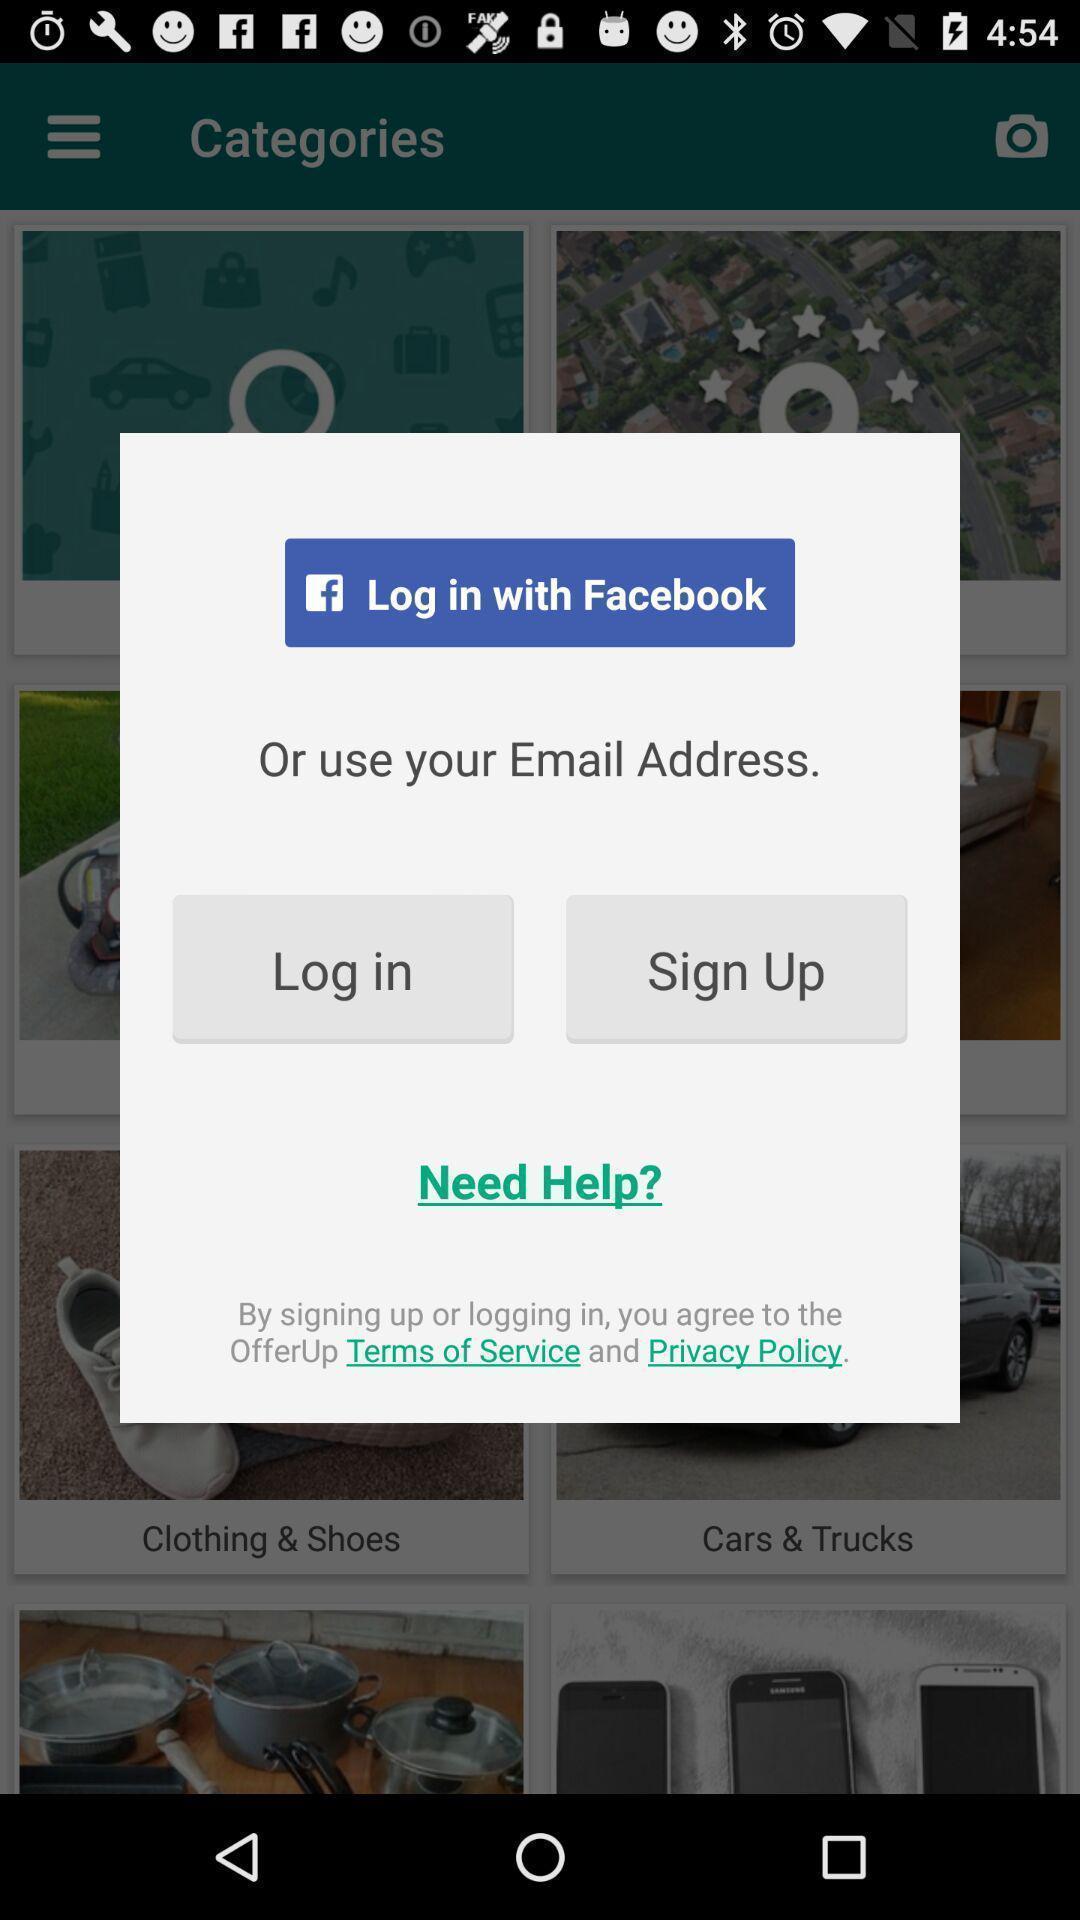Describe the content in this image. Pop-up to login to an app. 